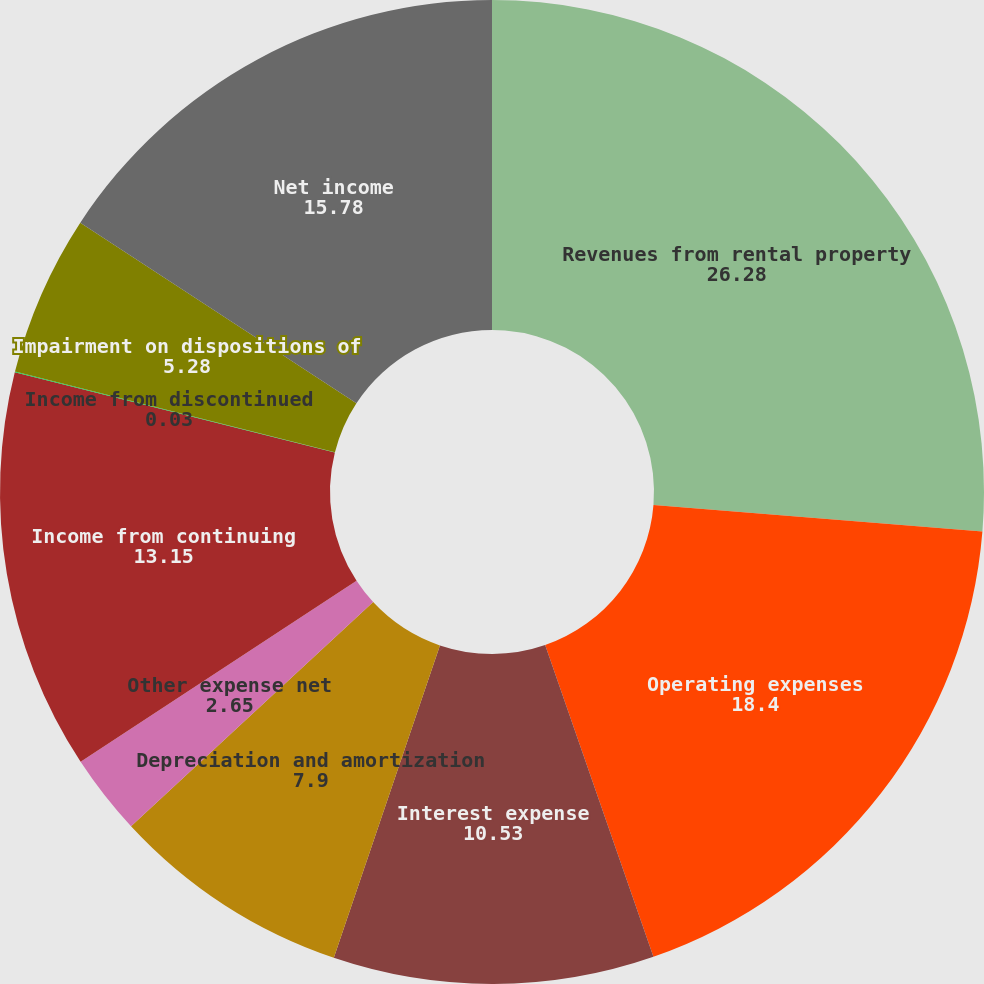Convert chart. <chart><loc_0><loc_0><loc_500><loc_500><pie_chart><fcel>Revenues from rental property<fcel>Operating expenses<fcel>Interest expense<fcel>Depreciation and amortization<fcel>Other expense net<fcel>Income from continuing<fcel>Income from discontinued<fcel>Impairment on dispositions of<fcel>Net income<nl><fcel>26.28%<fcel>18.4%<fcel>10.53%<fcel>7.9%<fcel>2.65%<fcel>13.15%<fcel>0.03%<fcel>5.28%<fcel>15.78%<nl></chart> 